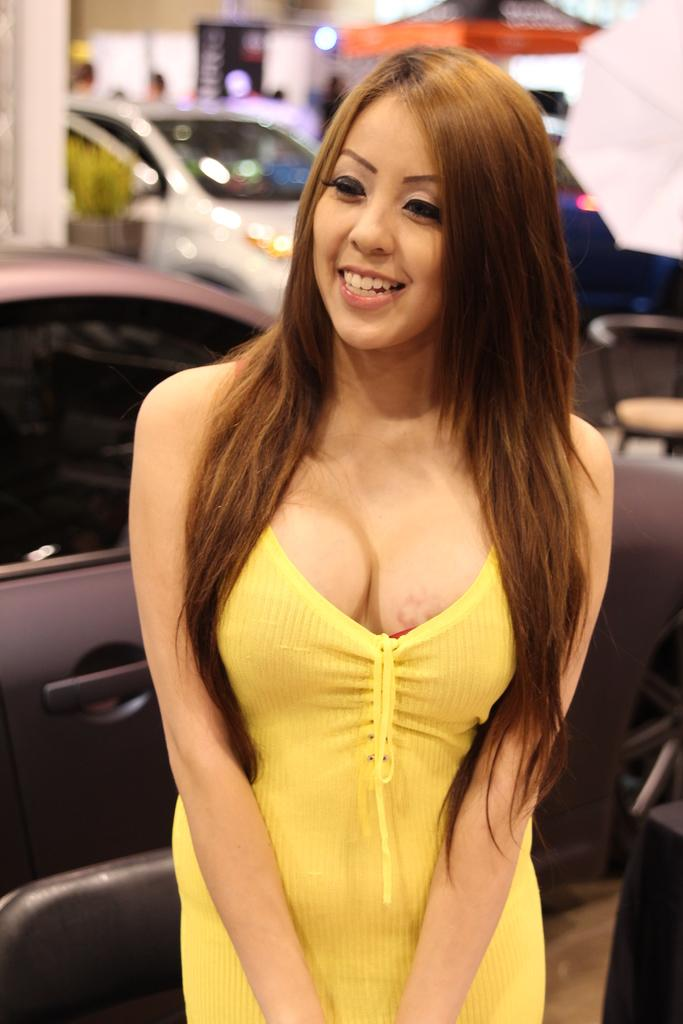Who is the main subject in the image? There is a woman in the image. What is the woman wearing? The woman is wearing a yellow dress. What is the woman's facial expression? The woman is smiling. Can you describe the background of the image? The background of the image is slightly blurred. What can be seen in the distance in the image? There are cars visible in the background of the image. What type of popcorn is the woman holding in the image? There is no popcorn present in the image; the woman is not holding anything. 